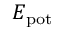<formula> <loc_0><loc_0><loc_500><loc_500>E _ { p o t }</formula> 